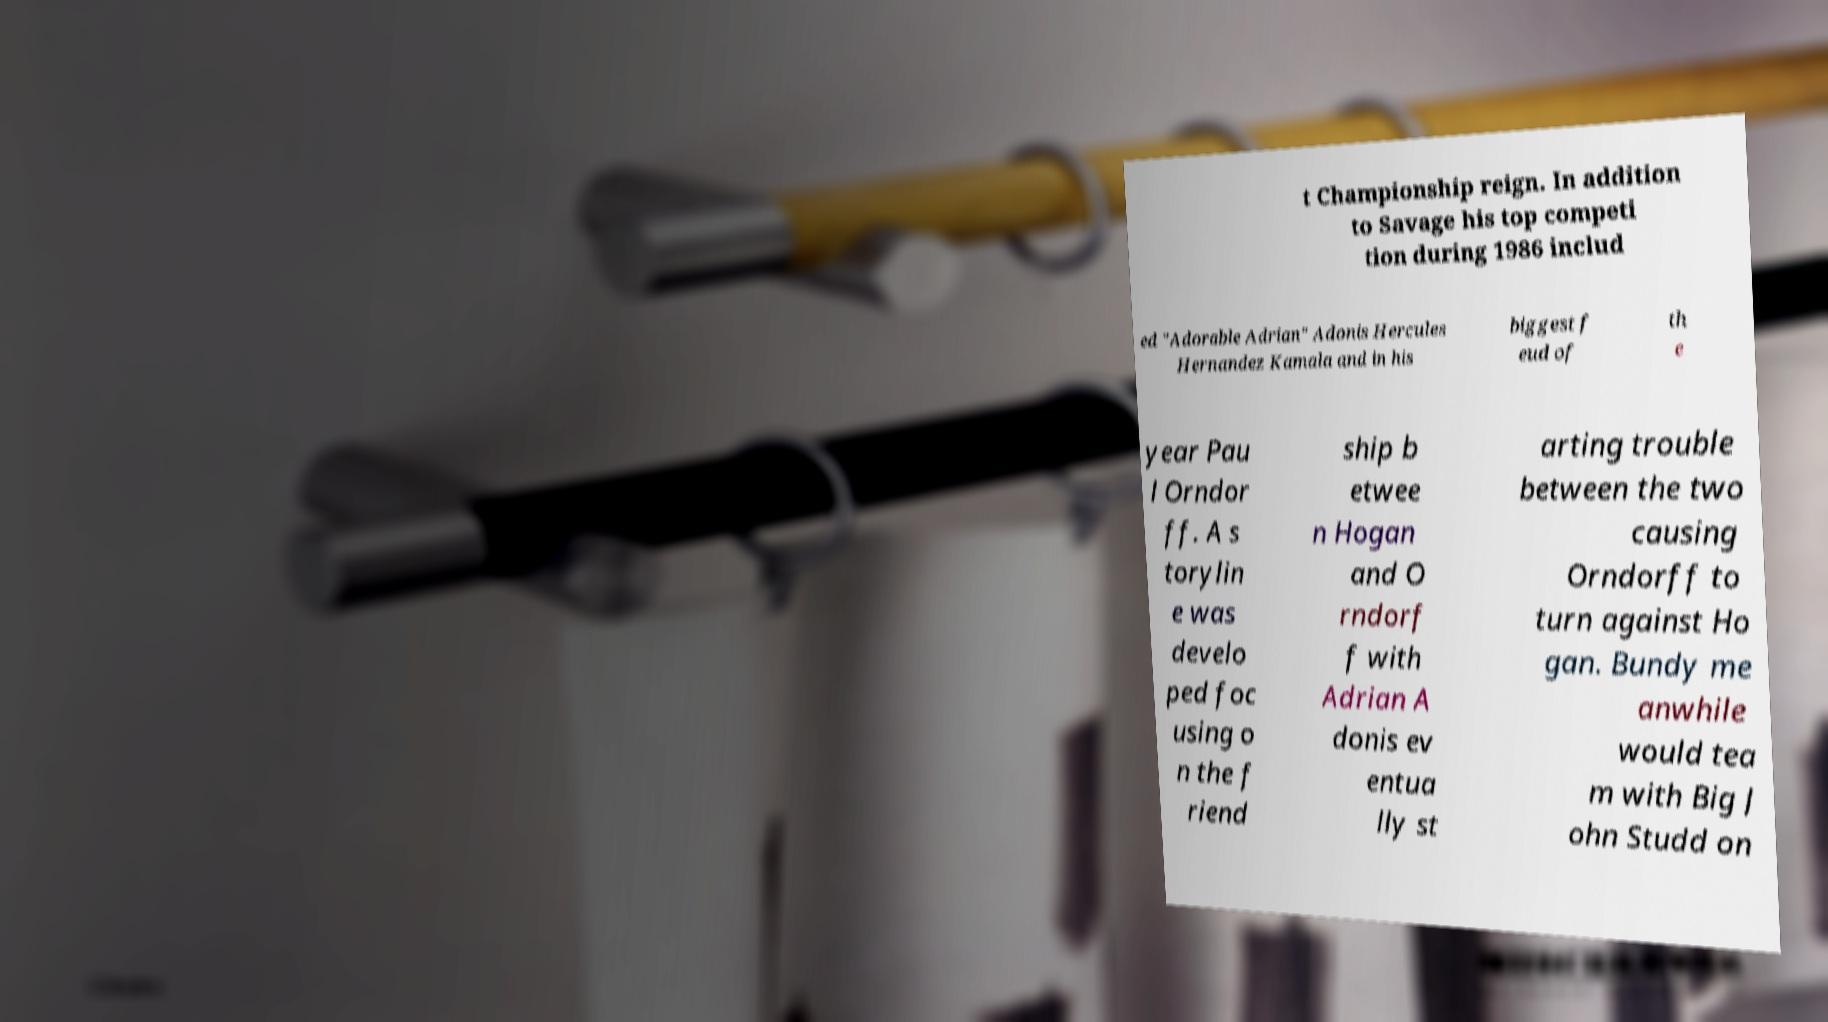Can you accurately transcribe the text from the provided image for me? t Championship reign. In addition to Savage his top competi tion during 1986 includ ed "Adorable Adrian" Adonis Hercules Hernandez Kamala and in his biggest f eud of th e year Pau l Orndor ff. A s torylin e was develo ped foc using o n the f riend ship b etwee n Hogan and O rndorf f with Adrian A donis ev entua lly st arting trouble between the two causing Orndorff to turn against Ho gan. Bundy me anwhile would tea m with Big J ohn Studd on 